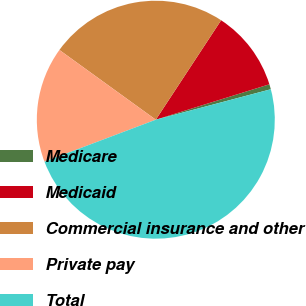<chart> <loc_0><loc_0><loc_500><loc_500><pie_chart><fcel>Medicare<fcel>Medicaid<fcel>Commercial insurance and other<fcel>Private pay<fcel>Total<nl><fcel>0.69%<fcel>10.94%<fcel>24.28%<fcel>15.71%<fcel>48.38%<nl></chart> 